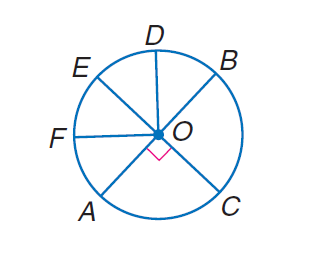Answer the mathemtical geometry problem and directly provide the correct option letter.
Question: In \odot O, E C and A B are diameters, and \angle B O D \cong \angle D O E \cong \angle E O F \cong \angle F O A. Find m \widehat C B F.
Choices: A: 45 B: 135 C: 180 D: 225 D 